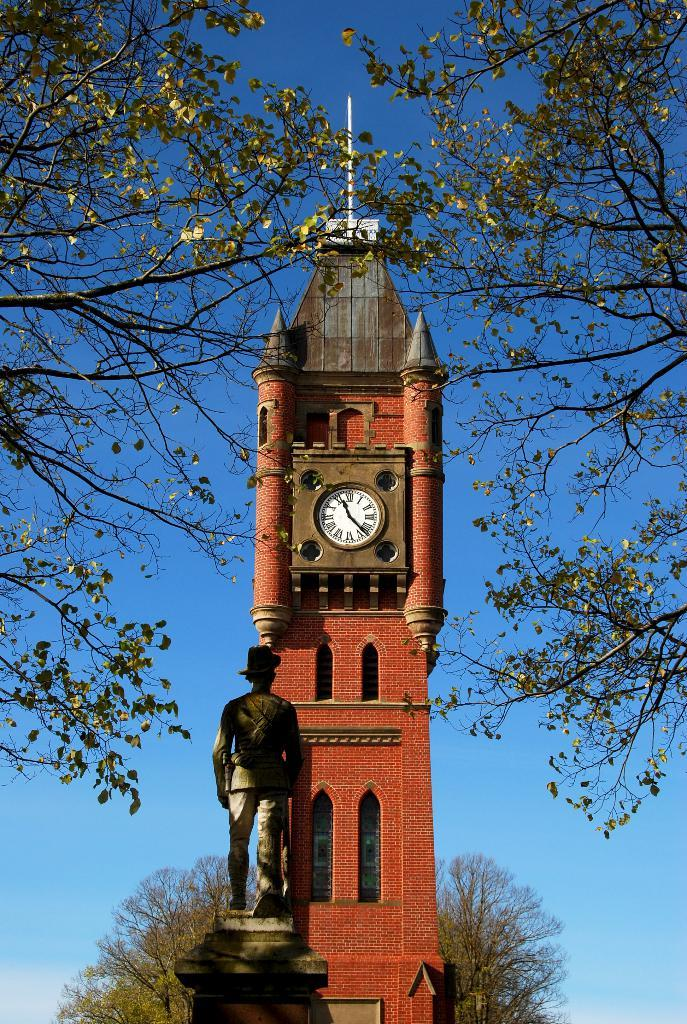<image>
Give a short and clear explanation of the subsequent image. A clock tower displaying a clock showing the time as 11:21 in Roman numerals. 